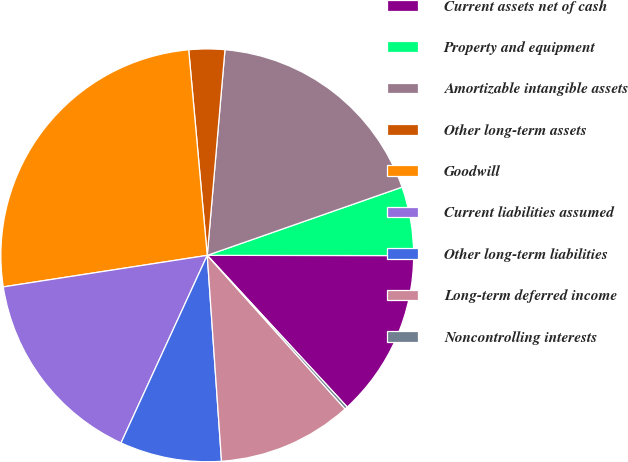Convert chart to OTSL. <chart><loc_0><loc_0><loc_500><loc_500><pie_chart><fcel>Current assets net of cash<fcel>Property and equipment<fcel>Amortizable intangible assets<fcel>Other long-term assets<fcel>Goodwill<fcel>Current liabilities assumed<fcel>Other long-term liabilities<fcel>Long-term deferred income<fcel>Noncontrolling interests<nl><fcel>13.12%<fcel>5.38%<fcel>18.27%<fcel>2.8%<fcel>26.01%<fcel>15.7%<fcel>7.96%<fcel>10.54%<fcel>0.22%<nl></chart> 